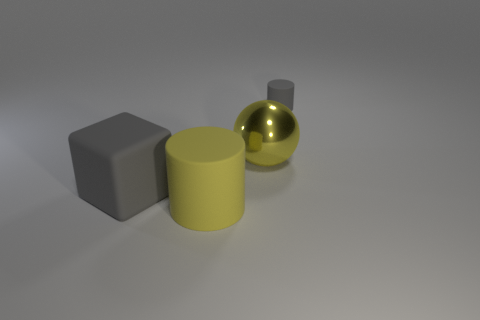Do the rubber block and the yellow thing behind the yellow cylinder have the same size? From the perspective provided in the image, it is not possible to definitively determine if the rubber block and the yellow object behind the yellow cylinder have exactly the same dimensions, as the angle and lighting could affect perception of size. However, they appear to be quite similar in size with the rubber block potentially being slightly larger. A direct measurement or an alternative viewing angle would provide a more accurate comparison. 